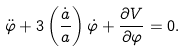<formula> <loc_0><loc_0><loc_500><loc_500>\ddot { \varphi } + 3 \left ( \frac { \dot { a } } { a } \right ) \dot { \varphi } + \frac { \partial V } { \partial \varphi } = 0 .</formula> 